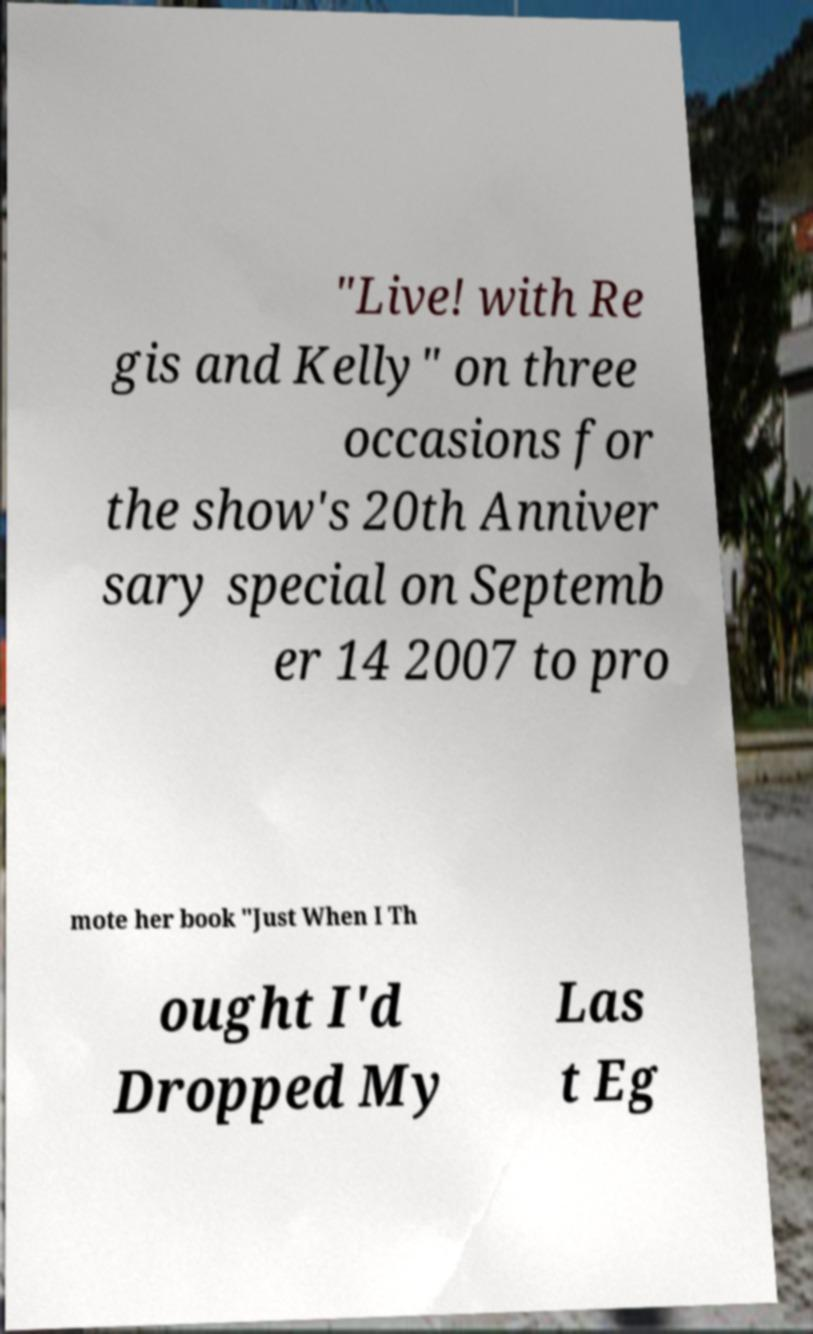For documentation purposes, I need the text within this image transcribed. Could you provide that? "Live! with Re gis and Kelly" on three occasions for the show's 20th Anniver sary special on Septemb er 14 2007 to pro mote her book "Just When I Th ought I'd Dropped My Las t Eg 